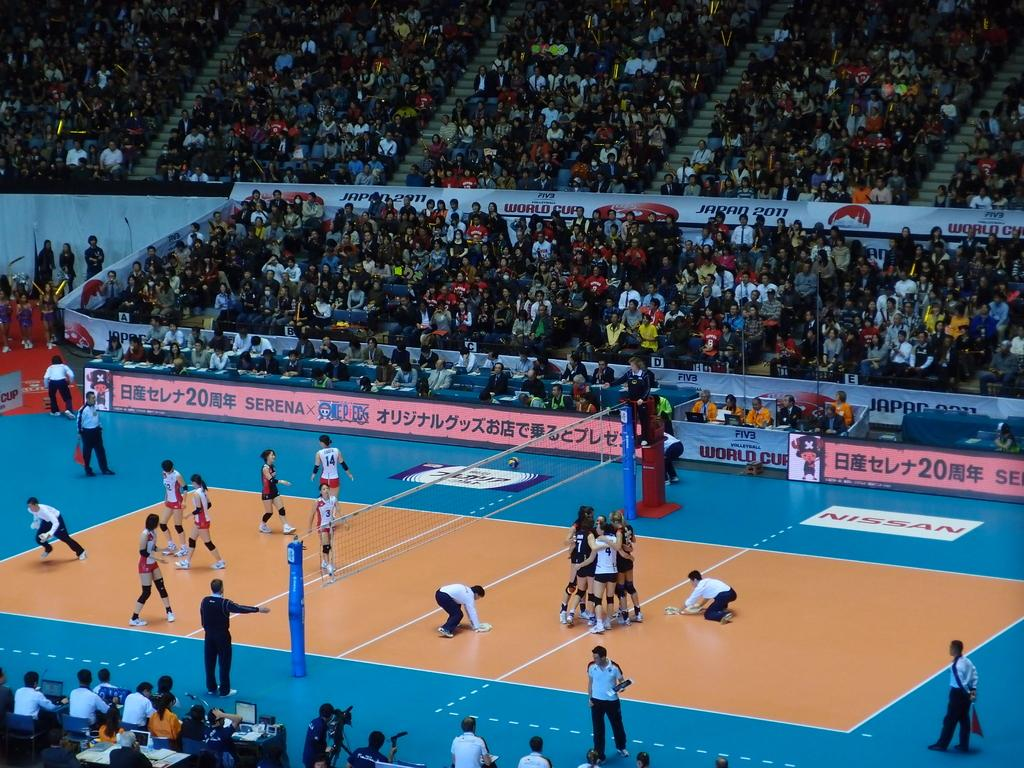<image>
Describe the image concisely. Volleyball players on the field  in front of an ad which says "WORLD CUP". 